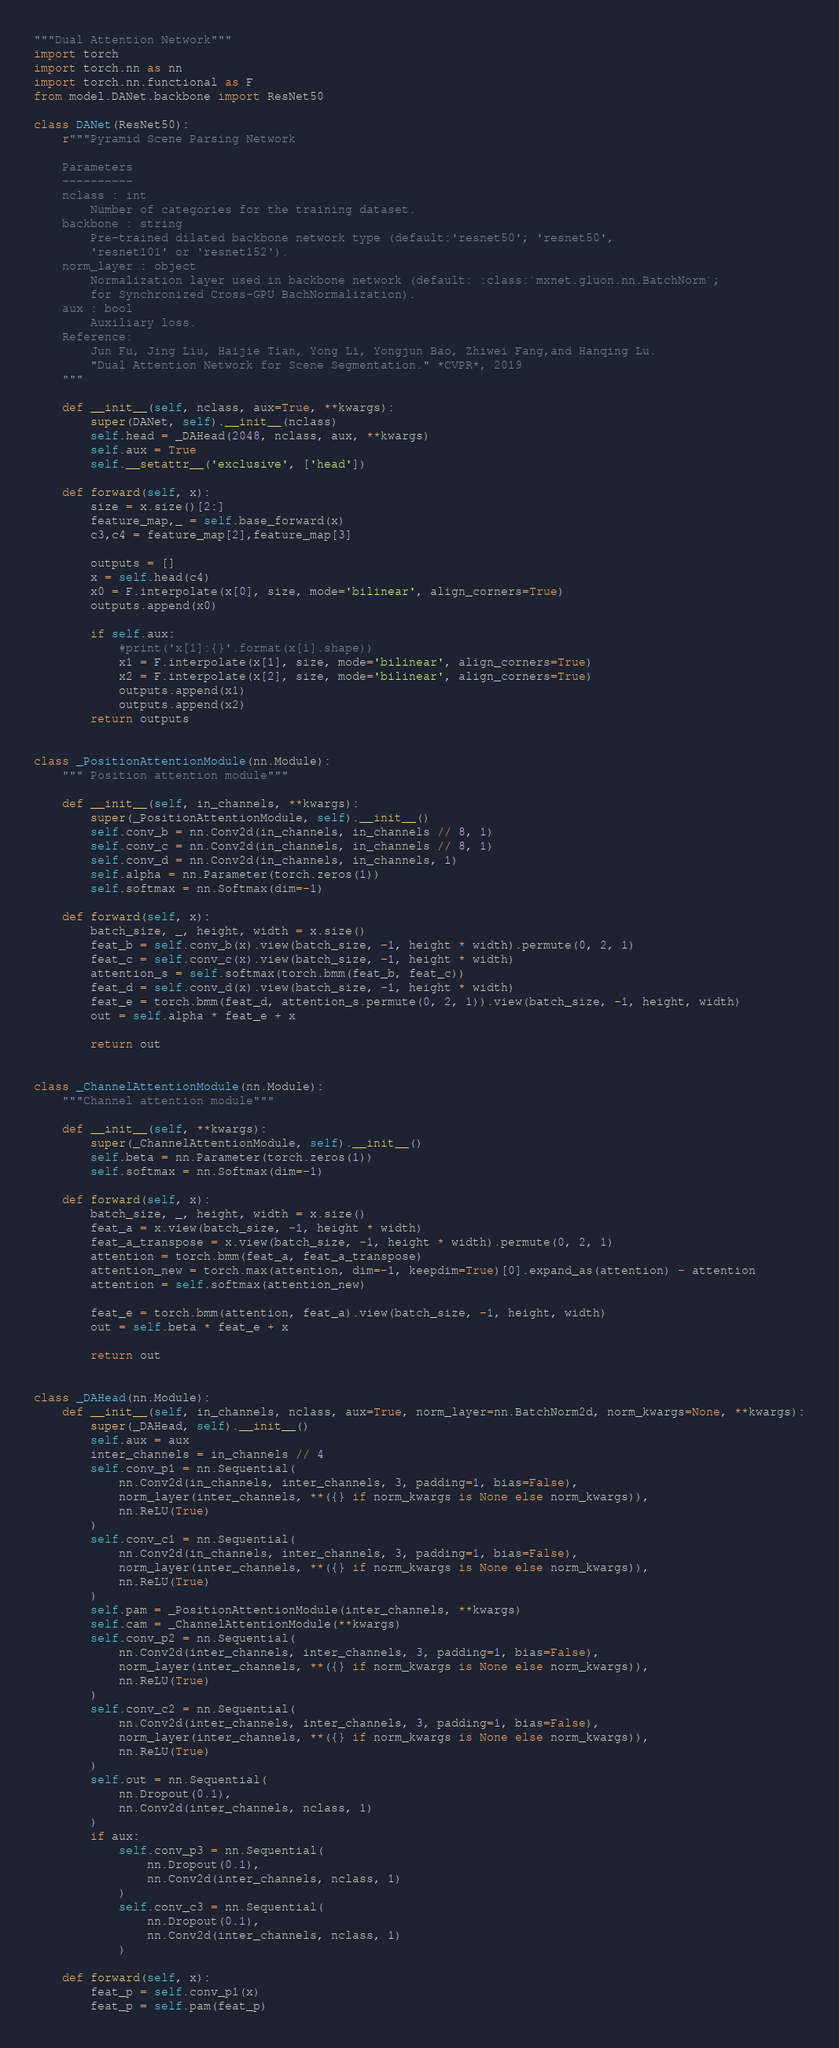Convert code to text. <code><loc_0><loc_0><loc_500><loc_500><_Python_>"""Dual Attention Network"""
import torch
import torch.nn as nn
import torch.nn.functional as F
from model.DANet.backbone import ResNet50

class DANet(ResNet50):
    r"""Pyramid Scene Parsing Network

    Parameters
    ----------
    nclass : int
        Number of categories for the training dataset.
    backbone : string
        Pre-trained dilated backbone network type (default:'resnet50'; 'resnet50',
        'resnet101' or 'resnet152').
    norm_layer : object
        Normalization layer used in backbone network (default: :class:`mxnet.gluon.nn.BatchNorm`;
        for Synchronized Cross-GPU BachNormalization).
    aux : bool
        Auxiliary loss.
    Reference:
        Jun Fu, Jing Liu, Haijie Tian, Yong Li, Yongjun Bao, Zhiwei Fang,and Hanqing Lu.
        "Dual Attention Network for Scene Segmentation." *CVPR*, 2019
    """

    def __init__(self, nclass, aux=True, **kwargs):
        super(DANet, self).__init__(nclass)
        self.head = _DAHead(2048, nclass, aux, **kwargs)
        self.aux = True
        self.__setattr__('exclusive', ['head'])

    def forward(self, x):
        size = x.size()[2:]
        feature_map,_ = self.base_forward(x)
        c3,c4 = feature_map[2],feature_map[3]

        outputs = []
        x = self.head(c4)
        x0 = F.interpolate(x[0], size, mode='bilinear', align_corners=True)
        outputs.append(x0)

        if self.aux:
            #print('x[1]:{}'.format(x[1].shape))
            x1 = F.interpolate(x[1], size, mode='bilinear', align_corners=True)
            x2 = F.interpolate(x[2], size, mode='bilinear', align_corners=True)
            outputs.append(x1)
            outputs.append(x2)
        return outputs


class _PositionAttentionModule(nn.Module):
    """ Position attention module"""

    def __init__(self, in_channels, **kwargs):
        super(_PositionAttentionModule, self).__init__()
        self.conv_b = nn.Conv2d(in_channels, in_channels // 8, 1)
        self.conv_c = nn.Conv2d(in_channels, in_channels // 8, 1)
        self.conv_d = nn.Conv2d(in_channels, in_channels, 1)
        self.alpha = nn.Parameter(torch.zeros(1))
        self.softmax = nn.Softmax(dim=-1)

    def forward(self, x):
        batch_size, _, height, width = x.size()
        feat_b = self.conv_b(x).view(batch_size, -1, height * width).permute(0, 2, 1)
        feat_c = self.conv_c(x).view(batch_size, -1, height * width)
        attention_s = self.softmax(torch.bmm(feat_b, feat_c))
        feat_d = self.conv_d(x).view(batch_size, -1, height * width)
        feat_e = torch.bmm(feat_d, attention_s.permute(0, 2, 1)).view(batch_size, -1, height, width)
        out = self.alpha * feat_e + x

        return out


class _ChannelAttentionModule(nn.Module):
    """Channel attention module"""

    def __init__(self, **kwargs):
        super(_ChannelAttentionModule, self).__init__()
        self.beta = nn.Parameter(torch.zeros(1))
        self.softmax = nn.Softmax(dim=-1)

    def forward(self, x):
        batch_size, _, height, width = x.size()
        feat_a = x.view(batch_size, -1, height * width)
        feat_a_transpose = x.view(batch_size, -1, height * width).permute(0, 2, 1)
        attention = torch.bmm(feat_a, feat_a_transpose)
        attention_new = torch.max(attention, dim=-1, keepdim=True)[0].expand_as(attention) - attention
        attention = self.softmax(attention_new)

        feat_e = torch.bmm(attention, feat_a).view(batch_size, -1, height, width)
        out = self.beta * feat_e + x

        return out


class _DAHead(nn.Module):
    def __init__(self, in_channels, nclass, aux=True, norm_layer=nn.BatchNorm2d, norm_kwargs=None, **kwargs):
        super(_DAHead, self).__init__()
        self.aux = aux
        inter_channels = in_channels // 4
        self.conv_p1 = nn.Sequential(
            nn.Conv2d(in_channels, inter_channels, 3, padding=1, bias=False),
            norm_layer(inter_channels, **({} if norm_kwargs is None else norm_kwargs)),
            nn.ReLU(True)
        )
        self.conv_c1 = nn.Sequential(
            nn.Conv2d(in_channels, inter_channels, 3, padding=1, bias=False),
            norm_layer(inter_channels, **({} if norm_kwargs is None else norm_kwargs)),
            nn.ReLU(True)
        )
        self.pam = _PositionAttentionModule(inter_channels, **kwargs)
        self.cam = _ChannelAttentionModule(**kwargs)
        self.conv_p2 = nn.Sequential(
            nn.Conv2d(inter_channels, inter_channels, 3, padding=1, bias=False),
            norm_layer(inter_channels, **({} if norm_kwargs is None else norm_kwargs)),
            nn.ReLU(True)
        )
        self.conv_c2 = nn.Sequential(
            nn.Conv2d(inter_channels, inter_channels, 3, padding=1, bias=False),
            norm_layer(inter_channels, **({} if norm_kwargs is None else norm_kwargs)),
            nn.ReLU(True)
        )
        self.out = nn.Sequential(
            nn.Dropout(0.1),
            nn.Conv2d(inter_channels, nclass, 1)
        )
        if aux:
            self.conv_p3 = nn.Sequential(
                nn.Dropout(0.1),
                nn.Conv2d(inter_channels, nclass, 1)
            )
            self.conv_c3 = nn.Sequential(
                nn.Dropout(0.1),
                nn.Conv2d(inter_channels, nclass, 1)
            )

    def forward(self, x):
        feat_p = self.conv_p1(x)
        feat_p = self.pam(feat_p)</code> 